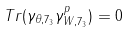Convert formula to latex. <formula><loc_0><loc_0><loc_500><loc_500>T r ( \gamma _ { \theta , 7 _ { 3 } } \gamma _ { W , 7 _ { 3 } } ^ { p } ) = 0</formula> 